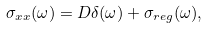<formula> <loc_0><loc_0><loc_500><loc_500>\sigma _ { x x } ( \omega ) = D \delta ( \omega ) + \sigma _ { r e g } ( \omega ) ,</formula> 